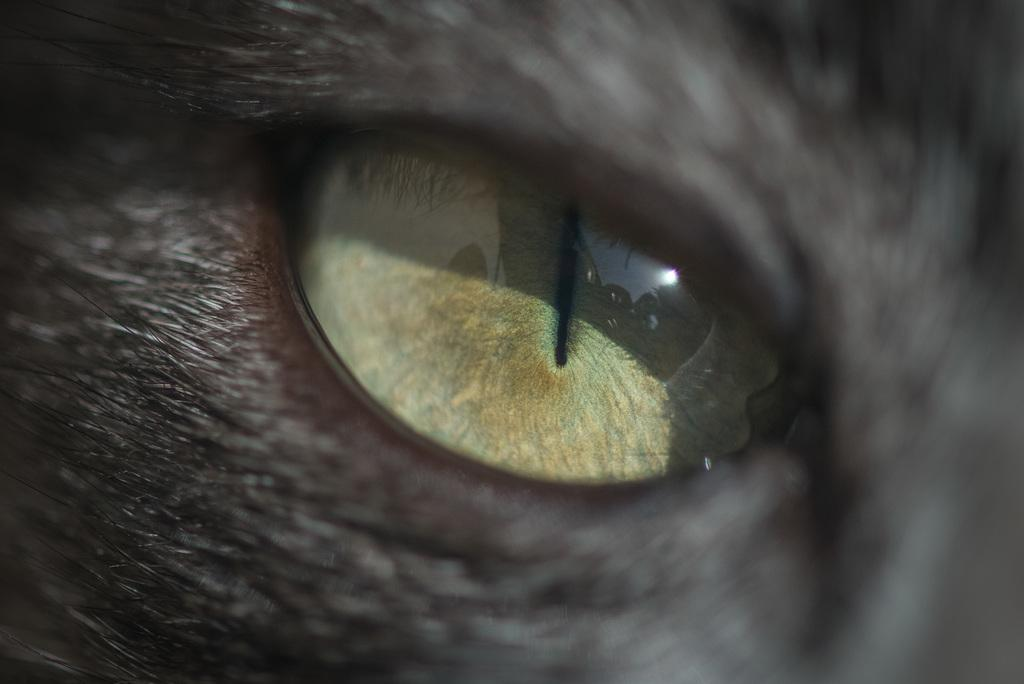What type of animal is in the picture? There is a black cat in the picture. What can be seen in the reflection of the cat's eye? There is a reflection of the sky and a tree in the cat's eye. What type of pest is visible in the field in the image? There is no field or pest present in the image; it features a black cat with reflections in its eye. 